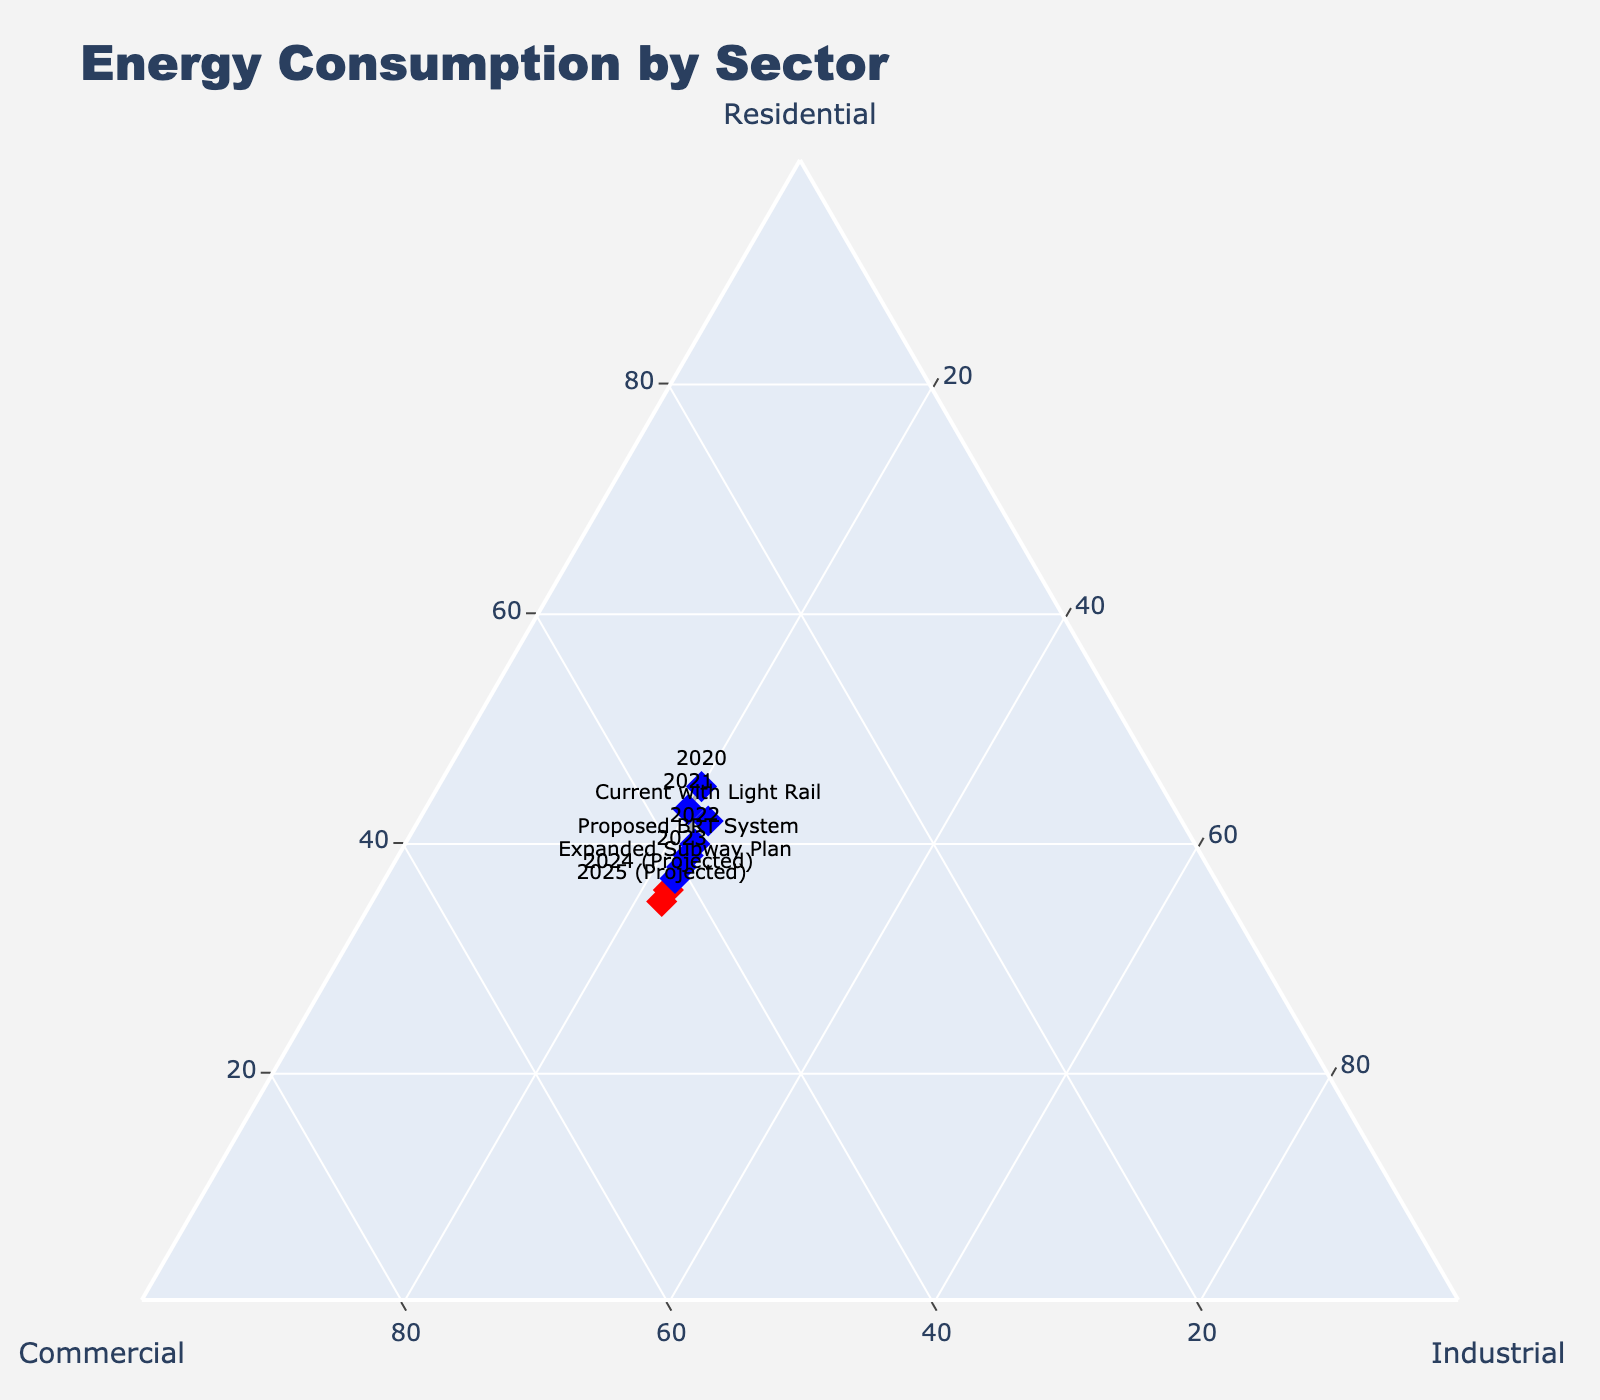What's the title of the figure? The title is usually prominently displayed at the top of the figure.
Answer: Energy Consumption by Sector What are the axis titles on the ternary plot? The axis titles are typically indicated along each axis.
Answer: Residential, Commercial, Industrial How many data points are shown for projected years? Count the data points labeled with 'Projected' in the text labels.
Answer: 2 Which sector has the highest percentage in 2020? Compare the values for Residential, Commercial, and Industrial in 2020.
Answer: Residential How does the energy consumption distribution differ between the current year with Light Rail and the proposed BRT System? Compare the values for the current year with Light Rail and the proposed BRT System. Residential: 42 vs. 39, Commercial: 36 vs. 39, Industrial: 22 vs. 22.
Answer: The proposed BRT System has a lower Residential and higher Commercial percentage compared to the current Light Rail Compare the projected sector values for 2024 and 2025. Are they increasing, decreasing, or stable? Check the values for each sector in 2024 and 2025. Residential: 36 to 35 (decreasing), Commercial: 42 to 43 (increasing), Industrial: 22 to 22 (stable).
Answer: Residential is decreasing, Commercial is increasing, Industrial is stable Between the Expanded Subway Plan and the proposed BRT System, which one shows the highest commercial energy consumption? Compare the Commercial values for the Expanded Subway Plan and the proposed BRT System.
Answer: Expanded Subway Plan What is the trend for Residential energy consumption from 2020 to 2025? Look at the values from 2020 to 2025 for Residential. 45, 43, 40, 38, 36, 35
Answer: Decreasing Which year or plan has the closest Residential and Commercial energy consumption percentages? Look for the data points where Residential and Commercial values are closest.
Answer: Proposed BRT System 